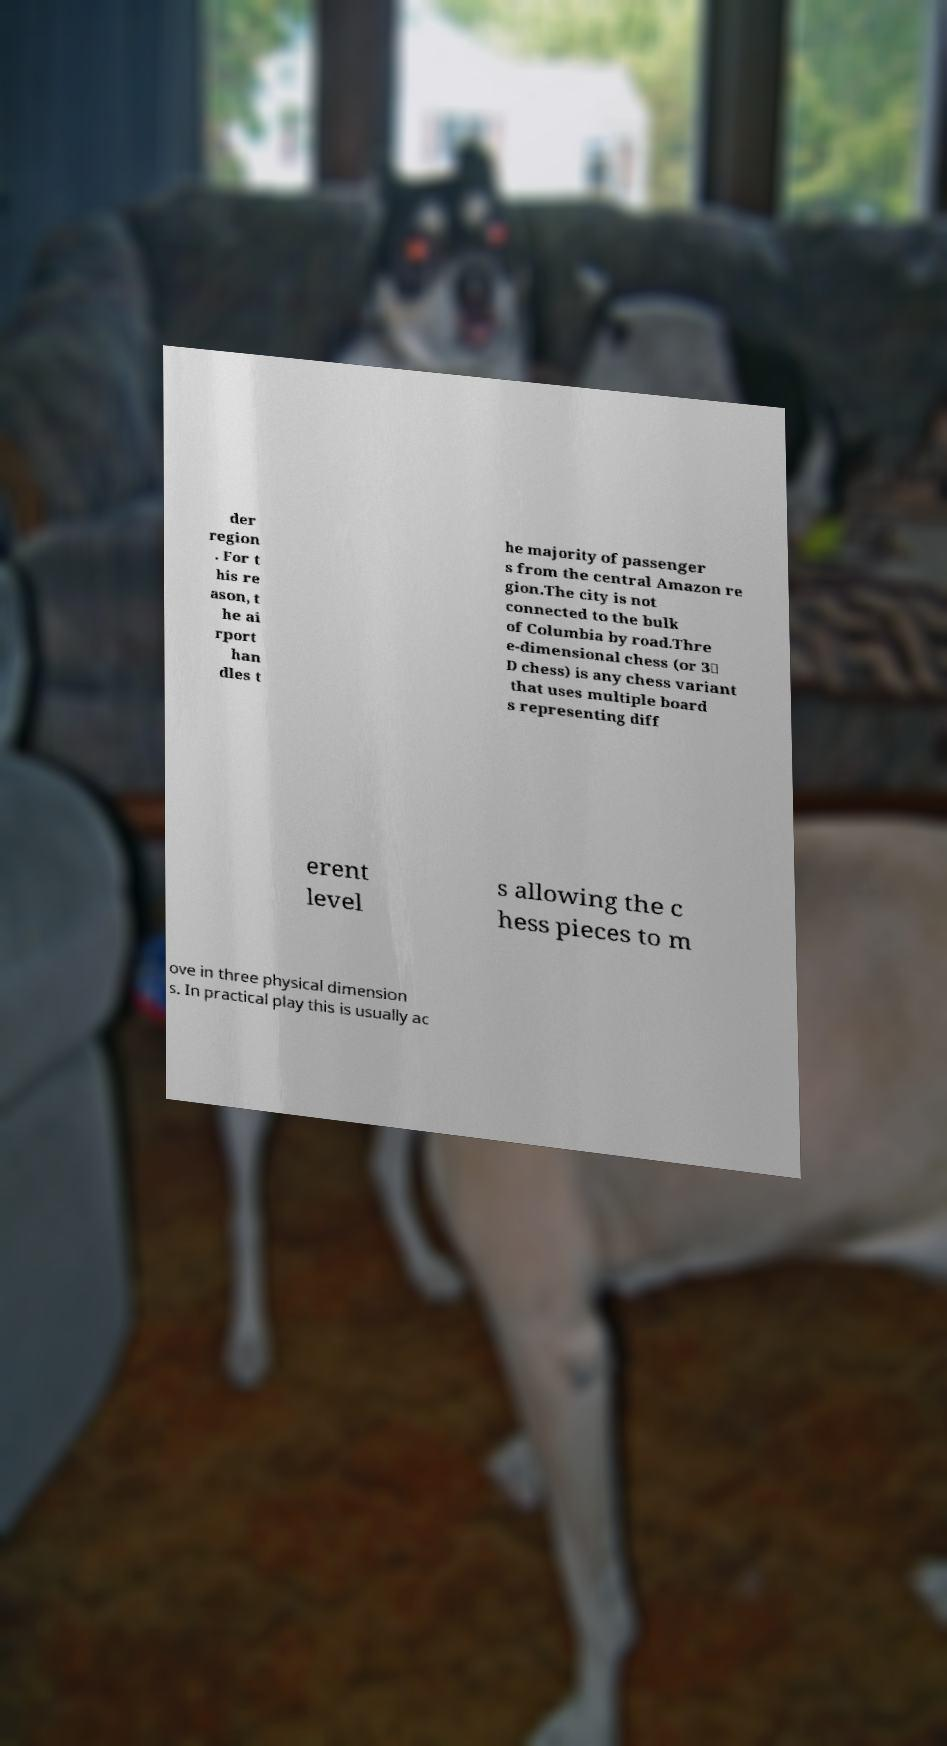What messages or text are displayed in this image? I need them in a readable, typed format. der region . For t his re ason, t he ai rport han dles t he majority of passenger s from the central Amazon re gion.The city is not connected to the bulk of Columbia by road.Thre e-dimensional chess (or 3‑ D chess) is any chess variant that uses multiple board s representing diff erent level s allowing the c hess pieces to m ove in three physical dimension s. In practical play this is usually ac 